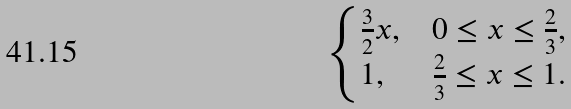<formula> <loc_0><loc_0><loc_500><loc_500>\begin{cases} \frac { 3 } { 2 } x , & 0 \leq x \leq \frac { 2 } { 3 } , \\ 1 , & \frac { 2 } { 3 } \leq x \leq 1 . \end{cases}</formula> 